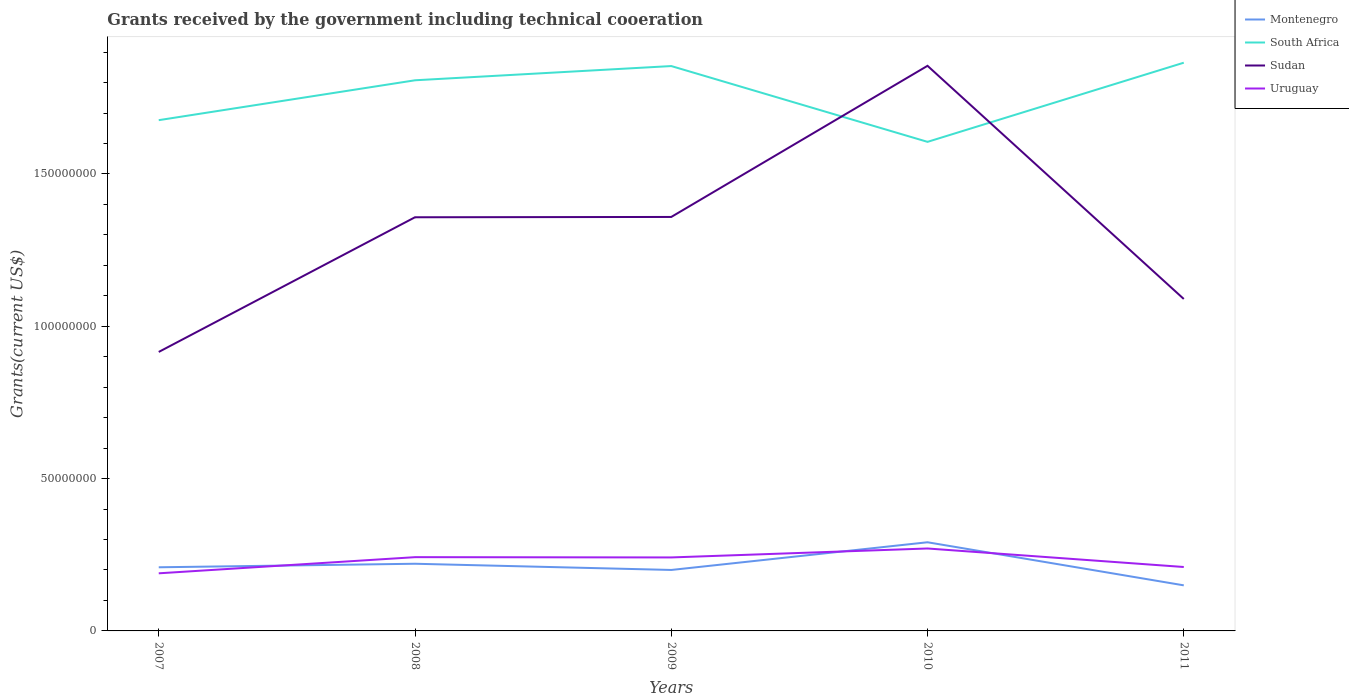Does the line corresponding to Montenegro intersect with the line corresponding to Uruguay?
Provide a succinct answer. Yes. Across all years, what is the maximum total grants received by the government in Sudan?
Your answer should be very brief. 9.16e+07. In which year was the total grants received by the government in Uruguay maximum?
Your answer should be very brief. 2007. What is the total total grants received by the government in South Africa in the graph?
Your answer should be very brief. -1.10e+06. What is the difference between the highest and the second highest total grants received by the government in South Africa?
Ensure brevity in your answer.  2.60e+07. What is the difference between the highest and the lowest total grants received by the government in Sudan?
Ensure brevity in your answer.  3. How many lines are there?
Make the answer very short. 4. How many years are there in the graph?
Your answer should be compact. 5. Are the values on the major ticks of Y-axis written in scientific E-notation?
Keep it short and to the point. No. How are the legend labels stacked?
Ensure brevity in your answer.  Vertical. What is the title of the graph?
Ensure brevity in your answer.  Grants received by the government including technical cooeration. What is the label or title of the Y-axis?
Your answer should be very brief. Grants(current US$). What is the Grants(current US$) of Montenegro in 2007?
Offer a terse response. 2.09e+07. What is the Grants(current US$) of South Africa in 2007?
Your response must be concise. 1.68e+08. What is the Grants(current US$) in Sudan in 2007?
Your answer should be very brief. 9.16e+07. What is the Grants(current US$) of Uruguay in 2007?
Your answer should be very brief. 1.89e+07. What is the Grants(current US$) in Montenegro in 2008?
Offer a terse response. 2.20e+07. What is the Grants(current US$) in South Africa in 2008?
Your answer should be compact. 1.81e+08. What is the Grants(current US$) in Sudan in 2008?
Make the answer very short. 1.36e+08. What is the Grants(current US$) of Uruguay in 2008?
Make the answer very short. 2.42e+07. What is the Grants(current US$) of Montenegro in 2009?
Make the answer very short. 2.00e+07. What is the Grants(current US$) in South Africa in 2009?
Your answer should be compact. 1.85e+08. What is the Grants(current US$) in Sudan in 2009?
Offer a very short reply. 1.36e+08. What is the Grants(current US$) in Uruguay in 2009?
Ensure brevity in your answer.  2.41e+07. What is the Grants(current US$) of Montenegro in 2010?
Your answer should be compact. 2.91e+07. What is the Grants(current US$) of South Africa in 2010?
Your answer should be compact. 1.61e+08. What is the Grants(current US$) of Sudan in 2010?
Offer a terse response. 1.85e+08. What is the Grants(current US$) of Uruguay in 2010?
Keep it short and to the point. 2.71e+07. What is the Grants(current US$) in Montenegro in 2011?
Your answer should be very brief. 1.50e+07. What is the Grants(current US$) in South Africa in 2011?
Your answer should be very brief. 1.87e+08. What is the Grants(current US$) of Sudan in 2011?
Offer a terse response. 1.09e+08. What is the Grants(current US$) in Uruguay in 2011?
Your answer should be compact. 2.10e+07. Across all years, what is the maximum Grants(current US$) of Montenegro?
Make the answer very short. 2.91e+07. Across all years, what is the maximum Grants(current US$) of South Africa?
Give a very brief answer. 1.87e+08. Across all years, what is the maximum Grants(current US$) of Sudan?
Ensure brevity in your answer.  1.85e+08. Across all years, what is the maximum Grants(current US$) of Uruguay?
Ensure brevity in your answer.  2.71e+07. Across all years, what is the minimum Grants(current US$) of Montenegro?
Offer a very short reply. 1.50e+07. Across all years, what is the minimum Grants(current US$) of South Africa?
Give a very brief answer. 1.61e+08. Across all years, what is the minimum Grants(current US$) of Sudan?
Provide a succinct answer. 9.16e+07. Across all years, what is the minimum Grants(current US$) in Uruguay?
Keep it short and to the point. 1.89e+07. What is the total Grants(current US$) in Montenegro in the graph?
Your answer should be very brief. 1.07e+08. What is the total Grants(current US$) in South Africa in the graph?
Provide a short and direct response. 8.81e+08. What is the total Grants(current US$) in Sudan in the graph?
Ensure brevity in your answer.  6.58e+08. What is the total Grants(current US$) in Uruguay in the graph?
Your answer should be compact. 1.15e+08. What is the difference between the Grants(current US$) in Montenegro in 2007 and that in 2008?
Your answer should be compact. -1.16e+06. What is the difference between the Grants(current US$) in South Africa in 2007 and that in 2008?
Your answer should be very brief. -1.31e+07. What is the difference between the Grants(current US$) in Sudan in 2007 and that in 2008?
Offer a terse response. -4.42e+07. What is the difference between the Grants(current US$) in Uruguay in 2007 and that in 2008?
Give a very brief answer. -5.30e+06. What is the difference between the Grants(current US$) of Montenegro in 2007 and that in 2009?
Keep it short and to the point. 8.80e+05. What is the difference between the Grants(current US$) of South Africa in 2007 and that in 2009?
Provide a short and direct response. -1.78e+07. What is the difference between the Grants(current US$) of Sudan in 2007 and that in 2009?
Provide a short and direct response. -4.43e+07. What is the difference between the Grants(current US$) in Uruguay in 2007 and that in 2009?
Your answer should be compact. -5.21e+06. What is the difference between the Grants(current US$) in Montenegro in 2007 and that in 2010?
Offer a very short reply. -8.21e+06. What is the difference between the Grants(current US$) in South Africa in 2007 and that in 2010?
Give a very brief answer. 7.12e+06. What is the difference between the Grants(current US$) in Sudan in 2007 and that in 2010?
Offer a very short reply. -9.39e+07. What is the difference between the Grants(current US$) of Uruguay in 2007 and that in 2010?
Your answer should be compact. -8.15e+06. What is the difference between the Grants(current US$) in Montenegro in 2007 and that in 2011?
Provide a short and direct response. 5.93e+06. What is the difference between the Grants(current US$) of South Africa in 2007 and that in 2011?
Your answer should be very brief. -1.89e+07. What is the difference between the Grants(current US$) in Sudan in 2007 and that in 2011?
Provide a succinct answer. -1.74e+07. What is the difference between the Grants(current US$) in Uruguay in 2007 and that in 2011?
Give a very brief answer. -2.07e+06. What is the difference between the Grants(current US$) of Montenegro in 2008 and that in 2009?
Your answer should be very brief. 2.04e+06. What is the difference between the Grants(current US$) of South Africa in 2008 and that in 2009?
Provide a short and direct response. -4.67e+06. What is the difference between the Grants(current US$) of Montenegro in 2008 and that in 2010?
Provide a succinct answer. -7.05e+06. What is the difference between the Grants(current US$) of South Africa in 2008 and that in 2010?
Offer a terse response. 2.02e+07. What is the difference between the Grants(current US$) of Sudan in 2008 and that in 2010?
Your answer should be compact. -4.97e+07. What is the difference between the Grants(current US$) of Uruguay in 2008 and that in 2010?
Provide a short and direct response. -2.85e+06. What is the difference between the Grants(current US$) in Montenegro in 2008 and that in 2011?
Provide a succinct answer. 7.09e+06. What is the difference between the Grants(current US$) of South Africa in 2008 and that in 2011?
Your response must be concise. -5.77e+06. What is the difference between the Grants(current US$) of Sudan in 2008 and that in 2011?
Your answer should be compact. 2.68e+07. What is the difference between the Grants(current US$) in Uruguay in 2008 and that in 2011?
Provide a short and direct response. 3.23e+06. What is the difference between the Grants(current US$) in Montenegro in 2009 and that in 2010?
Provide a succinct answer. -9.09e+06. What is the difference between the Grants(current US$) in South Africa in 2009 and that in 2010?
Give a very brief answer. 2.49e+07. What is the difference between the Grants(current US$) in Sudan in 2009 and that in 2010?
Ensure brevity in your answer.  -4.96e+07. What is the difference between the Grants(current US$) of Uruguay in 2009 and that in 2010?
Keep it short and to the point. -2.94e+06. What is the difference between the Grants(current US$) in Montenegro in 2009 and that in 2011?
Your answer should be very brief. 5.05e+06. What is the difference between the Grants(current US$) in South Africa in 2009 and that in 2011?
Offer a very short reply. -1.10e+06. What is the difference between the Grants(current US$) in Sudan in 2009 and that in 2011?
Offer a terse response. 2.69e+07. What is the difference between the Grants(current US$) in Uruguay in 2009 and that in 2011?
Give a very brief answer. 3.14e+06. What is the difference between the Grants(current US$) in Montenegro in 2010 and that in 2011?
Give a very brief answer. 1.41e+07. What is the difference between the Grants(current US$) in South Africa in 2010 and that in 2011?
Your answer should be compact. -2.60e+07. What is the difference between the Grants(current US$) in Sudan in 2010 and that in 2011?
Your answer should be very brief. 7.65e+07. What is the difference between the Grants(current US$) in Uruguay in 2010 and that in 2011?
Keep it short and to the point. 6.08e+06. What is the difference between the Grants(current US$) in Montenegro in 2007 and the Grants(current US$) in South Africa in 2008?
Provide a short and direct response. -1.60e+08. What is the difference between the Grants(current US$) of Montenegro in 2007 and the Grants(current US$) of Sudan in 2008?
Ensure brevity in your answer.  -1.15e+08. What is the difference between the Grants(current US$) of Montenegro in 2007 and the Grants(current US$) of Uruguay in 2008?
Make the answer very short. -3.32e+06. What is the difference between the Grants(current US$) in South Africa in 2007 and the Grants(current US$) in Sudan in 2008?
Offer a very short reply. 3.19e+07. What is the difference between the Grants(current US$) in South Africa in 2007 and the Grants(current US$) in Uruguay in 2008?
Offer a terse response. 1.43e+08. What is the difference between the Grants(current US$) of Sudan in 2007 and the Grants(current US$) of Uruguay in 2008?
Offer a very short reply. 6.74e+07. What is the difference between the Grants(current US$) in Montenegro in 2007 and the Grants(current US$) in South Africa in 2009?
Give a very brief answer. -1.65e+08. What is the difference between the Grants(current US$) of Montenegro in 2007 and the Grants(current US$) of Sudan in 2009?
Your response must be concise. -1.15e+08. What is the difference between the Grants(current US$) in Montenegro in 2007 and the Grants(current US$) in Uruguay in 2009?
Offer a very short reply. -3.23e+06. What is the difference between the Grants(current US$) of South Africa in 2007 and the Grants(current US$) of Sudan in 2009?
Your response must be concise. 3.18e+07. What is the difference between the Grants(current US$) in South Africa in 2007 and the Grants(current US$) in Uruguay in 2009?
Keep it short and to the point. 1.44e+08. What is the difference between the Grants(current US$) in Sudan in 2007 and the Grants(current US$) in Uruguay in 2009?
Ensure brevity in your answer.  6.74e+07. What is the difference between the Grants(current US$) of Montenegro in 2007 and the Grants(current US$) of South Africa in 2010?
Provide a short and direct response. -1.40e+08. What is the difference between the Grants(current US$) in Montenegro in 2007 and the Grants(current US$) in Sudan in 2010?
Provide a succinct answer. -1.65e+08. What is the difference between the Grants(current US$) of Montenegro in 2007 and the Grants(current US$) of Uruguay in 2010?
Make the answer very short. -6.17e+06. What is the difference between the Grants(current US$) of South Africa in 2007 and the Grants(current US$) of Sudan in 2010?
Offer a very short reply. -1.78e+07. What is the difference between the Grants(current US$) in South Africa in 2007 and the Grants(current US$) in Uruguay in 2010?
Your answer should be compact. 1.41e+08. What is the difference between the Grants(current US$) of Sudan in 2007 and the Grants(current US$) of Uruguay in 2010?
Ensure brevity in your answer.  6.45e+07. What is the difference between the Grants(current US$) of Montenegro in 2007 and the Grants(current US$) of South Africa in 2011?
Offer a terse response. -1.66e+08. What is the difference between the Grants(current US$) of Montenegro in 2007 and the Grants(current US$) of Sudan in 2011?
Ensure brevity in your answer.  -8.81e+07. What is the difference between the Grants(current US$) in South Africa in 2007 and the Grants(current US$) in Sudan in 2011?
Your answer should be very brief. 5.87e+07. What is the difference between the Grants(current US$) in South Africa in 2007 and the Grants(current US$) in Uruguay in 2011?
Offer a terse response. 1.47e+08. What is the difference between the Grants(current US$) of Sudan in 2007 and the Grants(current US$) of Uruguay in 2011?
Provide a succinct answer. 7.06e+07. What is the difference between the Grants(current US$) in Montenegro in 2008 and the Grants(current US$) in South Africa in 2009?
Your answer should be very brief. -1.63e+08. What is the difference between the Grants(current US$) in Montenegro in 2008 and the Grants(current US$) in Sudan in 2009?
Your answer should be very brief. -1.14e+08. What is the difference between the Grants(current US$) in Montenegro in 2008 and the Grants(current US$) in Uruguay in 2009?
Your answer should be compact. -2.07e+06. What is the difference between the Grants(current US$) in South Africa in 2008 and the Grants(current US$) in Sudan in 2009?
Provide a succinct answer. 4.49e+07. What is the difference between the Grants(current US$) of South Africa in 2008 and the Grants(current US$) of Uruguay in 2009?
Keep it short and to the point. 1.57e+08. What is the difference between the Grants(current US$) in Sudan in 2008 and the Grants(current US$) in Uruguay in 2009?
Offer a terse response. 1.12e+08. What is the difference between the Grants(current US$) of Montenegro in 2008 and the Grants(current US$) of South Africa in 2010?
Provide a short and direct response. -1.38e+08. What is the difference between the Grants(current US$) in Montenegro in 2008 and the Grants(current US$) in Sudan in 2010?
Offer a terse response. -1.63e+08. What is the difference between the Grants(current US$) of Montenegro in 2008 and the Grants(current US$) of Uruguay in 2010?
Offer a terse response. -5.01e+06. What is the difference between the Grants(current US$) of South Africa in 2008 and the Grants(current US$) of Sudan in 2010?
Your answer should be very brief. -4.75e+06. What is the difference between the Grants(current US$) of South Africa in 2008 and the Grants(current US$) of Uruguay in 2010?
Offer a very short reply. 1.54e+08. What is the difference between the Grants(current US$) in Sudan in 2008 and the Grants(current US$) in Uruguay in 2010?
Your response must be concise. 1.09e+08. What is the difference between the Grants(current US$) of Montenegro in 2008 and the Grants(current US$) of South Africa in 2011?
Offer a terse response. -1.64e+08. What is the difference between the Grants(current US$) in Montenegro in 2008 and the Grants(current US$) in Sudan in 2011?
Offer a very short reply. -8.69e+07. What is the difference between the Grants(current US$) of Montenegro in 2008 and the Grants(current US$) of Uruguay in 2011?
Your response must be concise. 1.07e+06. What is the difference between the Grants(current US$) in South Africa in 2008 and the Grants(current US$) in Sudan in 2011?
Offer a terse response. 7.18e+07. What is the difference between the Grants(current US$) of South Africa in 2008 and the Grants(current US$) of Uruguay in 2011?
Keep it short and to the point. 1.60e+08. What is the difference between the Grants(current US$) of Sudan in 2008 and the Grants(current US$) of Uruguay in 2011?
Your response must be concise. 1.15e+08. What is the difference between the Grants(current US$) in Montenegro in 2009 and the Grants(current US$) in South Africa in 2010?
Provide a short and direct response. -1.41e+08. What is the difference between the Grants(current US$) of Montenegro in 2009 and the Grants(current US$) of Sudan in 2010?
Keep it short and to the point. -1.65e+08. What is the difference between the Grants(current US$) in Montenegro in 2009 and the Grants(current US$) in Uruguay in 2010?
Your response must be concise. -7.05e+06. What is the difference between the Grants(current US$) in South Africa in 2009 and the Grants(current US$) in Uruguay in 2010?
Keep it short and to the point. 1.58e+08. What is the difference between the Grants(current US$) of Sudan in 2009 and the Grants(current US$) of Uruguay in 2010?
Give a very brief answer. 1.09e+08. What is the difference between the Grants(current US$) in Montenegro in 2009 and the Grants(current US$) in South Africa in 2011?
Offer a terse response. -1.66e+08. What is the difference between the Grants(current US$) of Montenegro in 2009 and the Grants(current US$) of Sudan in 2011?
Provide a succinct answer. -8.90e+07. What is the difference between the Grants(current US$) in Montenegro in 2009 and the Grants(current US$) in Uruguay in 2011?
Your answer should be compact. -9.70e+05. What is the difference between the Grants(current US$) of South Africa in 2009 and the Grants(current US$) of Sudan in 2011?
Your answer should be compact. 7.64e+07. What is the difference between the Grants(current US$) in South Africa in 2009 and the Grants(current US$) in Uruguay in 2011?
Provide a succinct answer. 1.64e+08. What is the difference between the Grants(current US$) of Sudan in 2009 and the Grants(current US$) of Uruguay in 2011?
Ensure brevity in your answer.  1.15e+08. What is the difference between the Grants(current US$) in Montenegro in 2010 and the Grants(current US$) in South Africa in 2011?
Offer a very short reply. -1.57e+08. What is the difference between the Grants(current US$) of Montenegro in 2010 and the Grants(current US$) of Sudan in 2011?
Offer a very short reply. -7.99e+07. What is the difference between the Grants(current US$) of Montenegro in 2010 and the Grants(current US$) of Uruguay in 2011?
Provide a succinct answer. 8.12e+06. What is the difference between the Grants(current US$) in South Africa in 2010 and the Grants(current US$) in Sudan in 2011?
Ensure brevity in your answer.  5.16e+07. What is the difference between the Grants(current US$) of South Africa in 2010 and the Grants(current US$) of Uruguay in 2011?
Offer a terse response. 1.40e+08. What is the difference between the Grants(current US$) of Sudan in 2010 and the Grants(current US$) of Uruguay in 2011?
Offer a very short reply. 1.65e+08. What is the average Grants(current US$) in Montenegro per year?
Your answer should be compact. 2.14e+07. What is the average Grants(current US$) in South Africa per year?
Make the answer very short. 1.76e+08. What is the average Grants(current US$) of Sudan per year?
Provide a succinct answer. 1.32e+08. What is the average Grants(current US$) of Uruguay per year?
Make the answer very short. 2.31e+07. In the year 2007, what is the difference between the Grants(current US$) in Montenegro and Grants(current US$) in South Africa?
Your answer should be very brief. -1.47e+08. In the year 2007, what is the difference between the Grants(current US$) of Montenegro and Grants(current US$) of Sudan?
Make the answer very short. -7.07e+07. In the year 2007, what is the difference between the Grants(current US$) of Montenegro and Grants(current US$) of Uruguay?
Ensure brevity in your answer.  1.98e+06. In the year 2007, what is the difference between the Grants(current US$) of South Africa and Grants(current US$) of Sudan?
Make the answer very short. 7.61e+07. In the year 2007, what is the difference between the Grants(current US$) of South Africa and Grants(current US$) of Uruguay?
Your answer should be compact. 1.49e+08. In the year 2007, what is the difference between the Grants(current US$) of Sudan and Grants(current US$) of Uruguay?
Your response must be concise. 7.27e+07. In the year 2008, what is the difference between the Grants(current US$) in Montenegro and Grants(current US$) in South Africa?
Provide a short and direct response. -1.59e+08. In the year 2008, what is the difference between the Grants(current US$) in Montenegro and Grants(current US$) in Sudan?
Your answer should be very brief. -1.14e+08. In the year 2008, what is the difference between the Grants(current US$) of Montenegro and Grants(current US$) of Uruguay?
Ensure brevity in your answer.  -2.16e+06. In the year 2008, what is the difference between the Grants(current US$) in South Africa and Grants(current US$) in Sudan?
Offer a terse response. 4.50e+07. In the year 2008, what is the difference between the Grants(current US$) of South Africa and Grants(current US$) of Uruguay?
Your response must be concise. 1.57e+08. In the year 2008, what is the difference between the Grants(current US$) in Sudan and Grants(current US$) in Uruguay?
Provide a succinct answer. 1.12e+08. In the year 2009, what is the difference between the Grants(current US$) in Montenegro and Grants(current US$) in South Africa?
Make the answer very short. -1.65e+08. In the year 2009, what is the difference between the Grants(current US$) in Montenegro and Grants(current US$) in Sudan?
Make the answer very short. -1.16e+08. In the year 2009, what is the difference between the Grants(current US$) of Montenegro and Grants(current US$) of Uruguay?
Provide a succinct answer. -4.11e+06. In the year 2009, what is the difference between the Grants(current US$) in South Africa and Grants(current US$) in Sudan?
Provide a short and direct response. 4.95e+07. In the year 2009, what is the difference between the Grants(current US$) in South Africa and Grants(current US$) in Uruguay?
Offer a terse response. 1.61e+08. In the year 2009, what is the difference between the Grants(current US$) of Sudan and Grants(current US$) of Uruguay?
Your answer should be very brief. 1.12e+08. In the year 2010, what is the difference between the Grants(current US$) of Montenegro and Grants(current US$) of South Africa?
Provide a succinct answer. -1.31e+08. In the year 2010, what is the difference between the Grants(current US$) in Montenegro and Grants(current US$) in Sudan?
Provide a succinct answer. -1.56e+08. In the year 2010, what is the difference between the Grants(current US$) of Montenegro and Grants(current US$) of Uruguay?
Your response must be concise. 2.04e+06. In the year 2010, what is the difference between the Grants(current US$) in South Africa and Grants(current US$) in Sudan?
Offer a very short reply. -2.50e+07. In the year 2010, what is the difference between the Grants(current US$) in South Africa and Grants(current US$) in Uruguay?
Keep it short and to the point. 1.33e+08. In the year 2010, what is the difference between the Grants(current US$) of Sudan and Grants(current US$) of Uruguay?
Ensure brevity in your answer.  1.58e+08. In the year 2011, what is the difference between the Grants(current US$) of Montenegro and Grants(current US$) of South Africa?
Your answer should be very brief. -1.72e+08. In the year 2011, what is the difference between the Grants(current US$) of Montenegro and Grants(current US$) of Sudan?
Make the answer very short. -9.40e+07. In the year 2011, what is the difference between the Grants(current US$) in Montenegro and Grants(current US$) in Uruguay?
Make the answer very short. -6.02e+06. In the year 2011, what is the difference between the Grants(current US$) in South Africa and Grants(current US$) in Sudan?
Ensure brevity in your answer.  7.76e+07. In the year 2011, what is the difference between the Grants(current US$) of South Africa and Grants(current US$) of Uruguay?
Your answer should be very brief. 1.66e+08. In the year 2011, what is the difference between the Grants(current US$) of Sudan and Grants(current US$) of Uruguay?
Make the answer very short. 8.80e+07. What is the ratio of the Grants(current US$) in Montenegro in 2007 to that in 2008?
Keep it short and to the point. 0.95. What is the ratio of the Grants(current US$) of South Africa in 2007 to that in 2008?
Your response must be concise. 0.93. What is the ratio of the Grants(current US$) of Sudan in 2007 to that in 2008?
Provide a succinct answer. 0.67. What is the ratio of the Grants(current US$) in Uruguay in 2007 to that in 2008?
Your answer should be compact. 0.78. What is the ratio of the Grants(current US$) of Montenegro in 2007 to that in 2009?
Your answer should be compact. 1.04. What is the ratio of the Grants(current US$) in South Africa in 2007 to that in 2009?
Provide a short and direct response. 0.9. What is the ratio of the Grants(current US$) of Sudan in 2007 to that in 2009?
Give a very brief answer. 0.67. What is the ratio of the Grants(current US$) in Uruguay in 2007 to that in 2009?
Your response must be concise. 0.78. What is the ratio of the Grants(current US$) of Montenegro in 2007 to that in 2010?
Ensure brevity in your answer.  0.72. What is the ratio of the Grants(current US$) of South Africa in 2007 to that in 2010?
Provide a succinct answer. 1.04. What is the ratio of the Grants(current US$) in Sudan in 2007 to that in 2010?
Make the answer very short. 0.49. What is the ratio of the Grants(current US$) in Uruguay in 2007 to that in 2010?
Provide a succinct answer. 0.7. What is the ratio of the Grants(current US$) of Montenegro in 2007 to that in 2011?
Your answer should be compact. 1.4. What is the ratio of the Grants(current US$) of South Africa in 2007 to that in 2011?
Make the answer very short. 0.9. What is the ratio of the Grants(current US$) of Sudan in 2007 to that in 2011?
Your answer should be very brief. 0.84. What is the ratio of the Grants(current US$) of Uruguay in 2007 to that in 2011?
Offer a very short reply. 0.9. What is the ratio of the Grants(current US$) of Montenegro in 2008 to that in 2009?
Offer a very short reply. 1.1. What is the ratio of the Grants(current US$) in South Africa in 2008 to that in 2009?
Provide a succinct answer. 0.97. What is the ratio of the Grants(current US$) of Uruguay in 2008 to that in 2009?
Give a very brief answer. 1. What is the ratio of the Grants(current US$) of Montenegro in 2008 to that in 2010?
Keep it short and to the point. 0.76. What is the ratio of the Grants(current US$) in South Africa in 2008 to that in 2010?
Your answer should be very brief. 1.13. What is the ratio of the Grants(current US$) of Sudan in 2008 to that in 2010?
Your answer should be very brief. 0.73. What is the ratio of the Grants(current US$) in Uruguay in 2008 to that in 2010?
Offer a very short reply. 0.89. What is the ratio of the Grants(current US$) in Montenegro in 2008 to that in 2011?
Ensure brevity in your answer.  1.47. What is the ratio of the Grants(current US$) of South Africa in 2008 to that in 2011?
Your answer should be very brief. 0.97. What is the ratio of the Grants(current US$) in Sudan in 2008 to that in 2011?
Provide a short and direct response. 1.25. What is the ratio of the Grants(current US$) of Uruguay in 2008 to that in 2011?
Provide a short and direct response. 1.15. What is the ratio of the Grants(current US$) in Montenegro in 2009 to that in 2010?
Keep it short and to the point. 0.69. What is the ratio of the Grants(current US$) in South Africa in 2009 to that in 2010?
Offer a terse response. 1.16. What is the ratio of the Grants(current US$) of Sudan in 2009 to that in 2010?
Keep it short and to the point. 0.73. What is the ratio of the Grants(current US$) in Uruguay in 2009 to that in 2010?
Your answer should be very brief. 0.89. What is the ratio of the Grants(current US$) in Montenegro in 2009 to that in 2011?
Your answer should be very brief. 1.34. What is the ratio of the Grants(current US$) in South Africa in 2009 to that in 2011?
Ensure brevity in your answer.  0.99. What is the ratio of the Grants(current US$) of Sudan in 2009 to that in 2011?
Your answer should be compact. 1.25. What is the ratio of the Grants(current US$) in Uruguay in 2009 to that in 2011?
Offer a terse response. 1.15. What is the ratio of the Grants(current US$) of Montenegro in 2010 to that in 2011?
Ensure brevity in your answer.  1.95. What is the ratio of the Grants(current US$) of South Africa in 2010 to that in 2011?
Your response must be concise. 0.86. What is the ratio of the Grants(current US$) in Sudan in 2010 to that in 2011?
Provide a succinct answer. 1.7. What is the ratio of the Grants(current US$) of Uruguay in 2010 to that in 2011?
Provide a succinct answer. 1.29. What is the difference between the highest and the second highest Grants(current US$) of Montenegro?
Offer a very short reply. 7.05e+06. What is the difference between the highest and the second highest Grants(current US$) of South Africa?
Your answer should be very brief. 1.10e+06. What is the difference between the highest and the second highest Grants(current US$) in Sudan?
Offer a terse response. 4.96e+07. What is the difference between the highest and the second highest Grants(current US$) of Uruguay?
Provide a succinct answer. 2.85e+06. What is the difference between the highest and the lowest Grants(current US$) of Montenegro?
Offer a terse response. 1.41e+07. What is the difference between the highest and the lowest Grants(current US$) of South Africa?
Keep it short and to the point. 2.60e+07. What is the difference between the highest and the lowest Grants(current US$) of Sudan?
Your answer should be compact. 9.39e+07. What is the difference between the highest and the lowest Grants(current US$) in Uruguay?
Your response must be concise. 8.15e+06. 